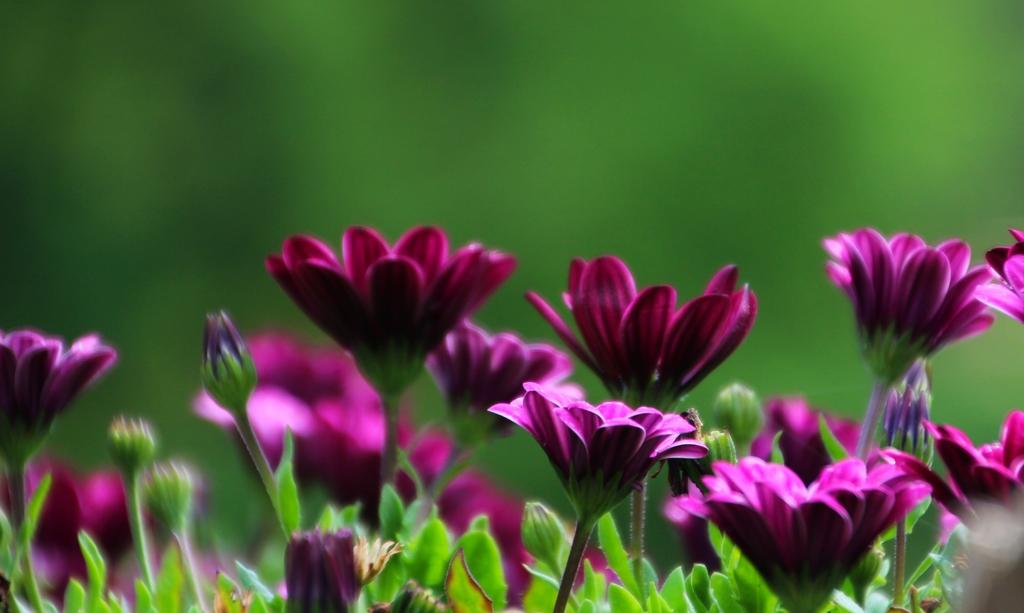What type of plant life is present in the image? There are flowers, buds, and leaves in the image. What is the color of the background in the image? The background of the image is green. What type of instrument is being played in the image? There is no instrument present in the image; it features plant life and a green background. What type of fabric is draped over the back of the chair in the image? There is no chair or fabric present in the image; it features plant life and a green background. 